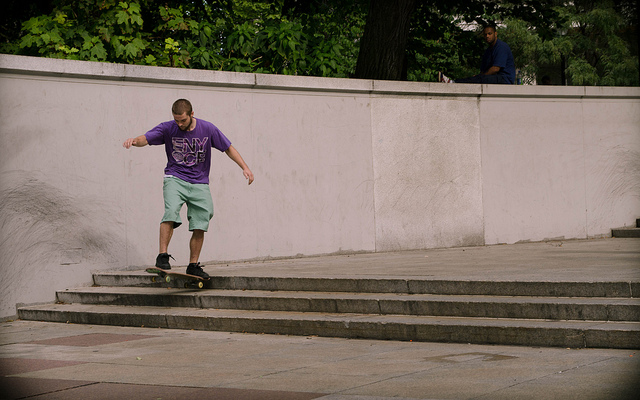Extract all visible text content from this image. NY 